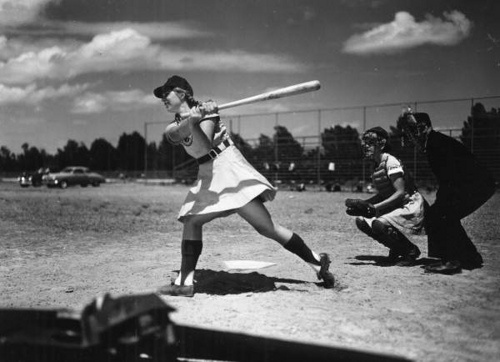Describe the objects in this image and their specific colors. I can see people in lightgray, gray, black, and darkgray tones, people in black, gray, darkgray, and lightgray tones, people in lightgray, black, gray, and darkgray tones, car in lightgray, black, gray, and darkgray tones, and baseball bat in lightgray, gray, darkgray, and black tones in this image. 